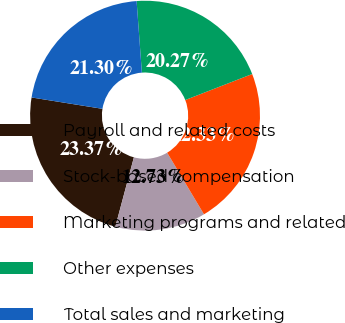<chart> <loc_0><loc_0><loc_500><loc_500><pie_chart><fcel>Payroll and related costs<fcel>Stock-based compensation<fcel>Marketing programs and related<fcel>Other expenses<fcel>Total sales and marketing<nl><fcel>23.37%<fcel>12.73%<fcel>22.33%<fcel>20.27%<fcel>21.3%<nl></chart> 